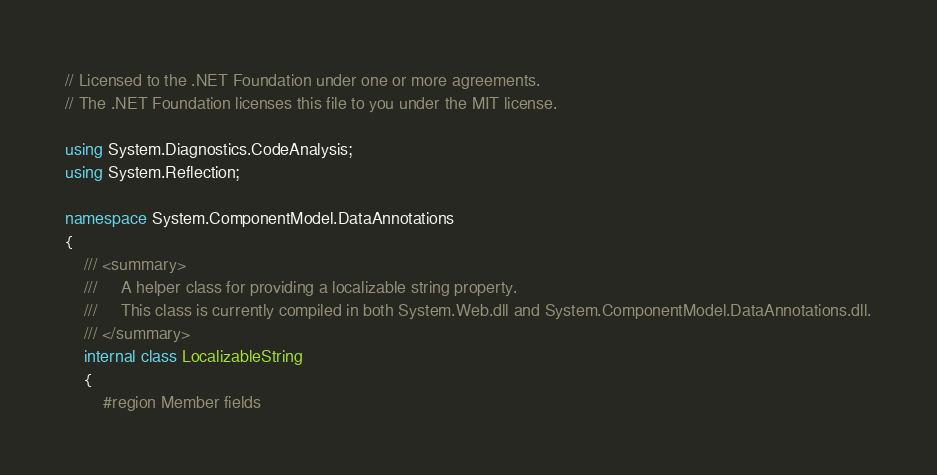<code> <loc_0><loc_0><loc_500><loc_500><_C#_>// Licensed to the .NET Foundation under one or more agreements.
// The .NET Foundation licenses this file to you under the MIT license.

using System.Diagnostics.CodeAnalysis;
using System.Reflection;

namespace System.ComponentModel.DataAnnotations
{
    /// <summary>
    ///     A helper class for providing a localizable string property.
    ///     This class is currently compiled in both System.Web.dll and System.ComponentModel.DataAnnotations.dll.
    /// </summary>
    internal class LocalizableString
    {
        #region Member fields
</code> 